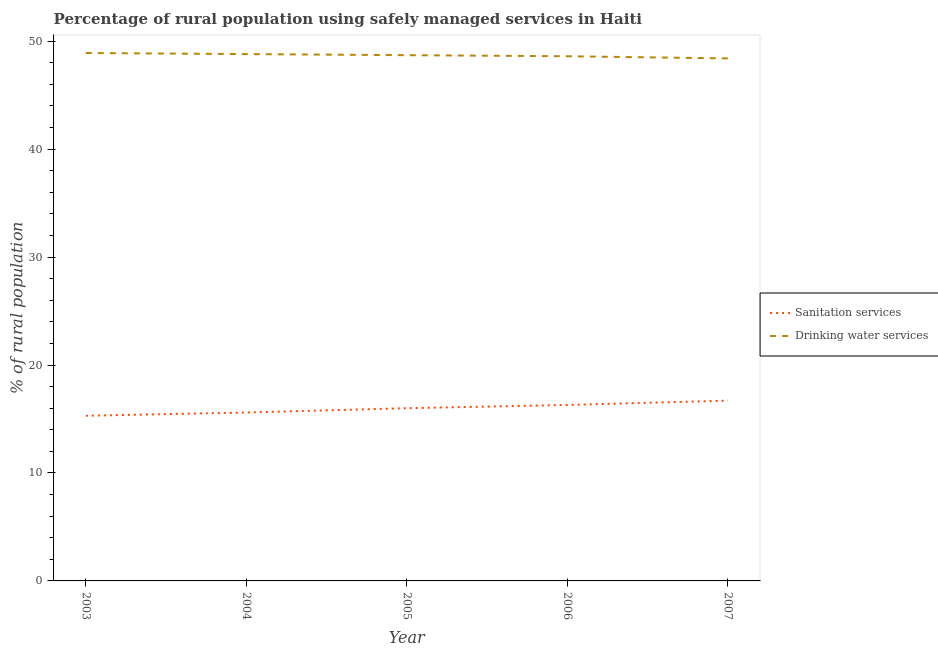What is the percentage of rural population who used drinking water services in 2003?
Your answer should be compact. 48.9. Across all years, what is the maximum percentage of rural population who used drinking water services?
Provide a short and direct response. 48.9. Across all years, what is the minimum percentage of rural population who used sanitation services?
Ensure brevity in your answer.  15.3. In which year was the percentage of rural population who used sanitation services minimum?
Offer a very short reply. 2003. What is the total percentage of rural population who used sanitation services in the graph?
Offer a very short reply. 79.9. What is the difference between the percentage of rural population who used sanitation services in 2005 and that in 2007?
Offer a terse response. -0.7. What is the difference between the percentage of rural population who used drinking water services in 2006 and the percentage of rural population who used sanitation services in 2005?
Keep it short and to the point. 32.6. What is the average percentage of rural population who used drinking water services per year?
Keep it short and to the point. 48.68. In the year 2006, what is the difference between the percentage of rural population who used drinking water services and percentage of rural population who used sanitation services?
Your answer should be compact. 32.3. What is the ratio of the percentage of rural population who used drinking water services in 2006 to that in 2007?
Provide a short and direct response. 1. Is the difference between the percentage of rural population who used sanitation services in 2004 and 2006 greater than the difference between the percentage of rural population who used drinking water services in 2004 and 2006?
Offer a terse response. No. What is the difference between the highest and the second highest percentage of rural population who used drinking water services?
Offer a very short reply. 0.1. What is the difference between the highest and the lowest percentage of rural population who used sanitation services?
Your answer should be very brief. 1.4. Is the sum of the percentage of rural population who used drinking water services in 2003 and 2004 greater than the maximum percentage of rural population who used sanitation services across all years?
Give a very brief answer. Yes. How many years are there in the graph?
Your answer should be very brief. 5. Are the values on the major ticks of Y-axis written in scientific E-notation?
Your answer should be very brief. No. Does the graph contain any zero values?
Your answer should be compact. No. Does the graph contain grids?
Your answer should be compact. No. How are the legend labels stacked?
Offer a terse response. Vertical. What is the title of the graph?
Provide a short and direct response. Percentage of rural population using safely managed services in Haiti. Does "Import" appear as one of the legend labels in the graph?
Make the answer very short. No. What is the label or title of the Y-axis?
Provide a short and direct response. % of rural population. What is the % of rural population of Drinking water services in 2003?
Your response must be concise. 48.9. What is the % of rural population of Drinking water services in 2004?
Ensure brevity in your answer.  48.8. What is the % of rural population of Sanitation services in 2005?
Make the answer very short. 16. What is the % of rural population of Drinking water services in 2005?
Give a very brief answer. 48.7. What is the % of rural population in Sanitation services in 2006?
Offer a terse response. 16.3. What is the % of rural population of Drinking water services in 2006?
Keep it short and to the point. 48.6. What is the % of rural population in Drinking water services in 2007?
Provide a short and direct response. 48.4. Across all years, what is the maximum % of rural population of Drinking water services?
Provide a succinct answer. 48.9. Across all years, what is the minimum % of rural population in Sanitation services?
Provide a short and direct response. 15.3. Across all years, what is the minimum % of rural population of Drinking water services?
Provide a short and direct response. 48.4. What is the total % of rural population of Sanitation services in the graph?
Your answer should be very brief. 79.9. What is the total % of rural population in Drinking water services in the graph?
Keep it short and to the point. 243.4. What is the difference between the % of rural population of Sanitation services in 2003 and that in 2004?
Provide a succinct answer. -0.3. What is the difference between the % of rural population of Drinking water services in 2003 and that in 2004?
Provide a succinct answer. 0.1. What is the difference between the % of rural population in Sanitation services in 2003 and that in 2005?
Your answer should be very brief. -0.7. What is the difference between the % of rural population of Drinking water services in 2003 and that in 2005?
Provide a short and direct response. 0.2. What is the difference between the % of rural population of Sanitation services in 2004 and that in 2005?
Keep it short and to the point. -0.4. What is the difference between the % of rural population of Sanitation services in 2004 and that in 2006?
Provide a short and direct response. -0.7. What is the difference between the % of rural population of Drinking water services in 2004 and that in 2006?
Provide a short and direct response. 0.2. What is the difference between the % of rural population of Sanitation services in 2005 and that in 2006?
Make the answer very short. -0.3. What is the difference between the % of rural population in Drinking water services in 2005 and that in 2006?
Offer a terse response. 0.1. What is the difference between the % of rural population in Sanitation services in 2005 and that in 2007?
Offer a very short reply. -0.7. What is the difference between the % of rural population of Drinking water services in 2005 and that in 2007?
Keep it short and to the point. 0.3. What is the difference between the % of rural population of Sanitation services in 2006 and that in 2007?
Your response must be concise. -0.4. What is the difference between the % of rural population of Sanitation services in 2003 and the % of rural population of Drinking water services in 2004?
Provide a short and direct response. -33.5. What is the difference between the % of rural population of Sanitation services in 2003 and the % of rural population of Drinking water services in 2005?
Your answer should be very brief. -33.4. What is the difference between the % of rural population of Sanitation services in 2003 and the % of rural population of Drinking water services in 2006?
Offer a terse response. -33.3. What is the difference between the % of rural population of Sanitation services in 2003 and the % of rural population of Drinking water services in 2007?
Your answer should be very brief. -33.1. What is the difference between the % of rural population of Sanitation services in 2004 and the % of rural population of Drinking water services in 2005?
Offer a terse response. -33.1. What is the difference between the % of rural population in Sanitation services in 2004 and the % of rural population in Drinking water services in 2006?
Keep it short and to the point. -33. What is the difference between the % of rural population of Sanitation services in 2004 and the % of rural population of Drinking water services in 2007?
Your answer should be very brief. -32.8. What is the difference between the % of rural population in Sanitation services in 2005 and the % of rural population in Drinking water services in 2006?
Ensure brevity in your answer.  -32.6. What is the difference between the % of rural population of Sanitation services in 2005 and the % of rural population of Drinking water services in 2007?
Provide a succinct answer. -32.4. What is the difference between the % of rural population in Sanitation services in 2006 and the % of rural population in Drinking water services in 2007?
Give a very brief answer. -32.1. What is the average % of rural population of Sanitation services per year?
Your response must be concise. 15.98. What is the average % of rural population of Drinking water services per year?
Offer a very short reply. 48.68. In the year 2003, what is the difference between the % of rural population of Sanitation services and % of rural population of Drinking water services?
Give a very brief answer. -33.6. In the year 2004, what is the difference between the % of rural population of Sanitation services and % of rural population of Drinking water services?
Give a very brief answer. -33.2. In the year 2005, what is the difference between the % of rural population of Sanitation services and % of rural population of Drinking water services?
Keep it short and to the point. -32.7. In the year 2006, what is the difference between the % of rural population in Sanitation services and % of rural population in Drinking water services?
Your answer should be very brief. -32.3. In the year 2007, what is the difference between the % of rural population in Sanitation services and % of rural population in Drinking water services?
Your answer should be compact. -31.7. What is the ratio of the % of rural population of Sanitation services in 2003 to that in 2004?
Provide a succinct answer. 0.98. What is the ratio of the % of rural population of Sanitation services in 2003 to that in 2005?
Provide a succinct answer. 0.96. What is the ratio of the % of rural population in Sanitation services in 2003 to that in 2006?
Give a very brief answer. 0.94. What is the ratio of the % of rural population of Drinking water services in 2003 to that in 2006?
Make the answer very short. 1.01. What is the ratio of the % of rural population of Sanitation services in 2003 to that in 2007?
Provide a short and direct response. 0.92. What is the ratio of the % of rural population of Drinking water services in 2003 to that in 2007?
Ensure brevity in your answer.  1.01. What is the ratio of the % of rural population in Sanitation services in 2004 to that in 2006?
Make the answer very short. 0.96. What is the ratio of the % of rural population in Sanitation services in 2004 to that in 2007?
Your answer should be very brief. 0.93. What is the ratio of the % of rural population of Drinking water services in 2004 to that in 2007?
Provide a short and direct response. 1.01. What is the ratio of the % of rural population of Sanitation services in 2005 to that in 2006?
Offer a very short reply. 0.98. What is the ratio of the % of rural population in Drinking water services in 2005 to that in 2006?
Make the answer very short. 1. What is the ratio of the % of rural population in Sanitation services in 2005 to that in 2007?
Your answer should be compact. 0.96. What is the ratio of the % of rural population of Sanitation services in 2006 to that in 2007?
Your answer should be very brief. 0.98. What is the ratio of the % of rural population in Drinking water services in 2006 to that in 2007?
Your response must be concise. 1. What is the difference between the highest and the second highest % of rural population of Drinking water services?
Your response must be concise. 0.1. 